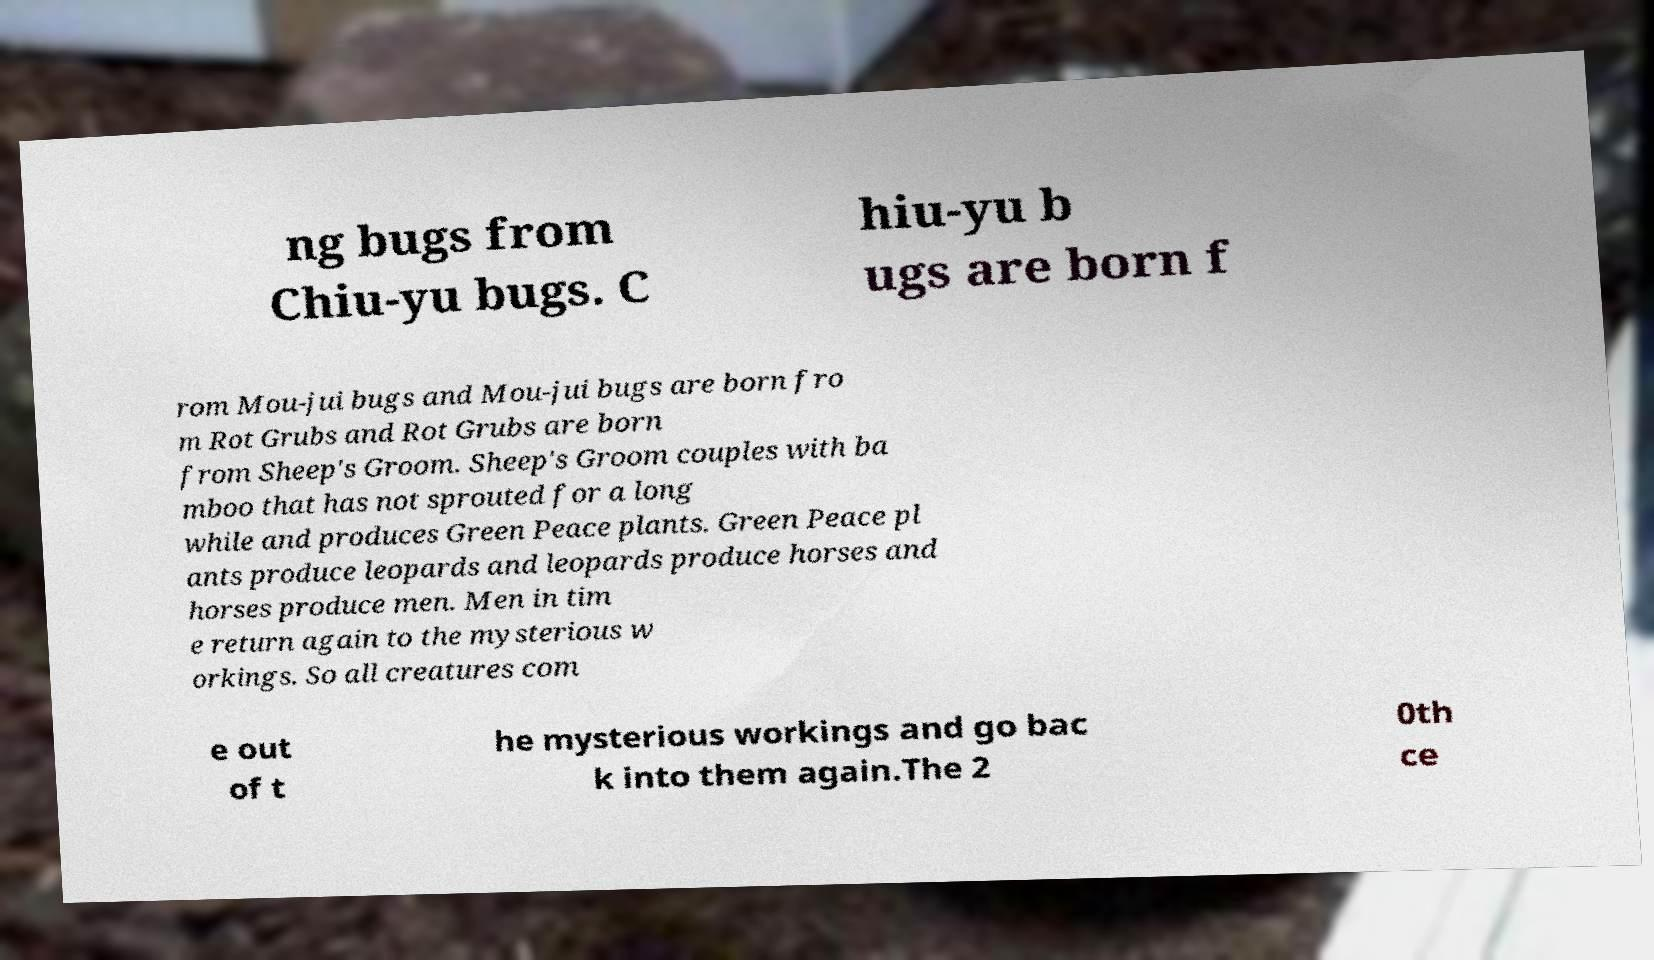Please identify and transcribe the text found in this image. ng bugs from Chiu-yu bugs. C hiu-yu b ugs are born f rom Mou-jui bugs and Mou-jui bugs are born fro m Rot Grubs and Rot Grubs are born from Sheep's Groom. Sheep's Groom couples with ba mboo that has not sprouted for a long while and produces Green Peace plants. Green Peace pl ants produce leopards and leopards produce horses and horses produce men. Men in tim e return again to the mysterious w orkings. So all creatures com e out of t he mysterious workings and go bac k into them again.The 2 0th ce 